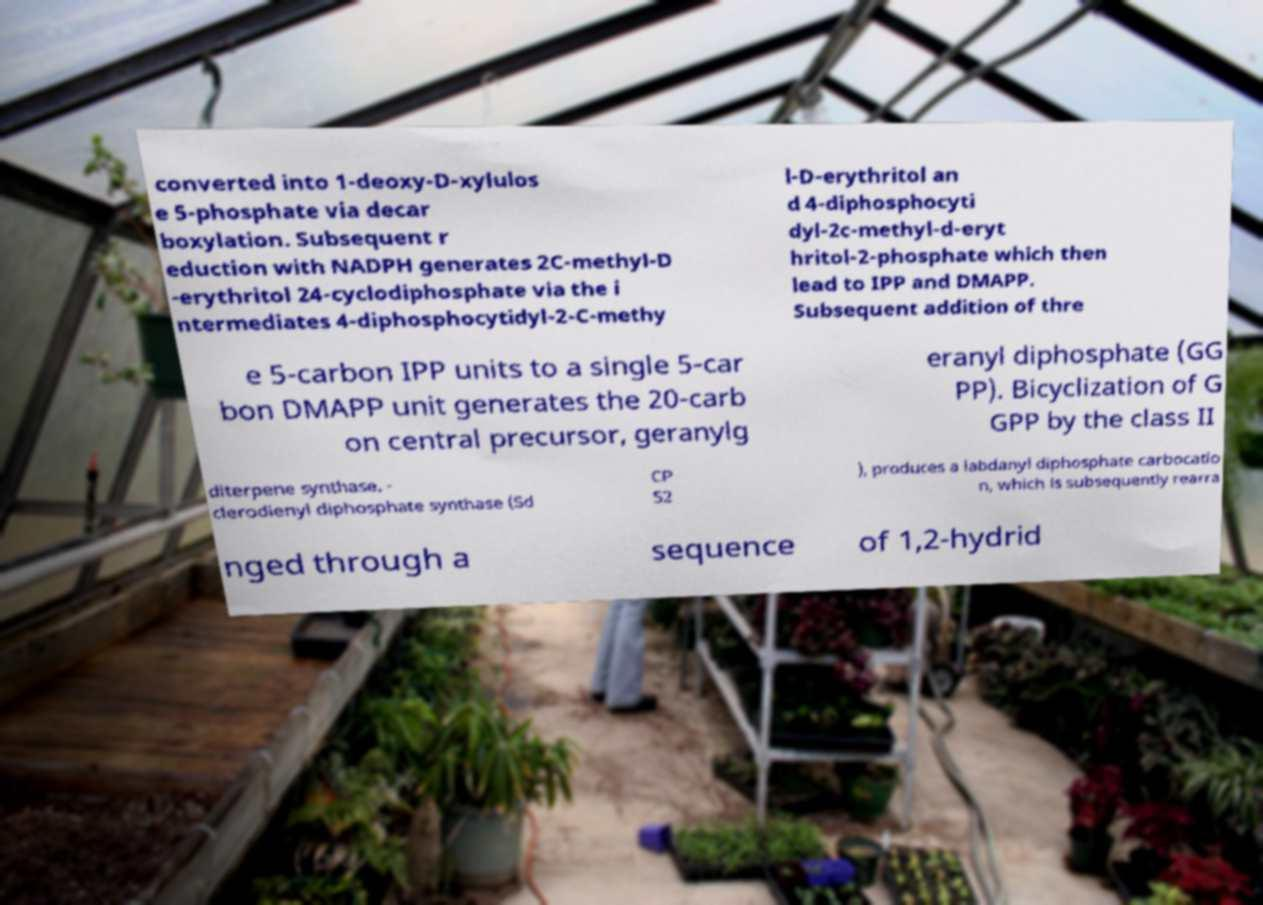Can you read and provide the text displayed in the image?This photo seems to have some interesting text. Can you extract and type it out for me? converted into 1-deoxy-D-xylulos e 5-phosphate via decar boxylation. Subsequent r eduction with NADPH generates 2C-methyl-D -erythritol 24-cyclodiphosphate via the i ntermediates 4-diphosphocytidyl-2-C-methy l-D-erythritol an d 4-diphosphocyti dyl-2c-methyl-d-eryt hritol-2-phosphate which then lead to IPP and DMAPP. Subsequent addition of thre e 5-carbon IPP units to a single 5-car bon DMAPP unit generates the 20-carb on central precursor, geranylg eranyl diphosphate (GG PP). Bicyclization of G GPP by the class II diterpene synthase, - clerodienyl diphosphate synthase (Sd CP S2 ), produces a labdanyl diphosphate carbocatio n, which is subsequently rearra nged through a sequence of 1,2-hydrid 